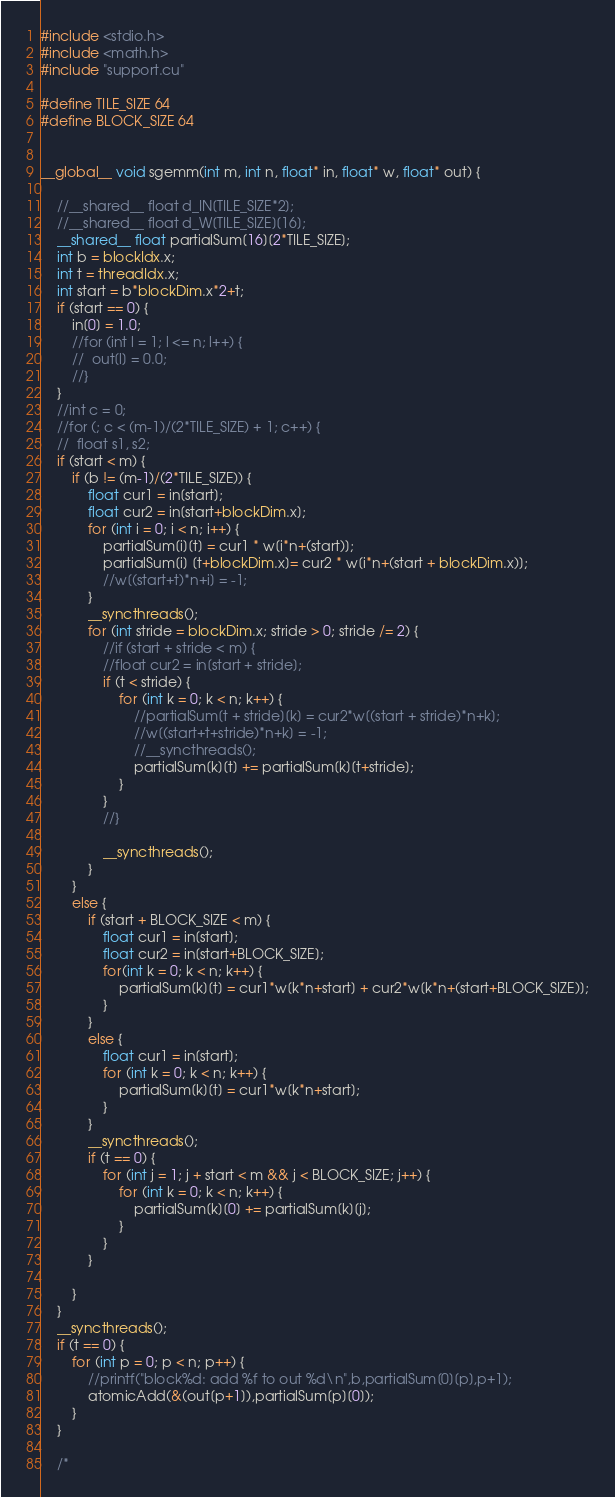Convert code to text. <code><loc_0><loc_0><loc_500><loc_500><_Cuda_>#include <stdio.h>
#include <math.h>
#include "support.cu"

#define TILE_SIZE 64
#define BLOCK_SIZE 64


__global__ void sgemm(int m, int n, float* in, float* w, float* out) {

	//__shared__ float d_IN[TILE_SIZE*2];
	//__shared__ float d_W[TILE_SIZE][16];
	__shared__ float partialSum[16][2*TILE_SIZE];
	int b = blockIdx.x;
	int t = threadIdx.x;
	int start = b*blockDim.x*2+t;
	if (start == 0) {
		in[0] = 1.0;
		//for (int l = 1; l <= n; l++) {
		//	out[l] = 0.0;
		//}
	}
	//int c = 0;
	//for (; c < (m-1)/(2*TILE_SIZE) + 1; c++) {
	//	float s1, s2;
	if (start < m) {
		if (b != (m-1)/(2*TILE_SIZE)) {
			float cur1 = in[start];
			float cur2 = in[start+blockDim.x];
			for (int i = 0; i < n; i++) {			
				partialSum[i][t] = cur1 * w[i*n+(start)];
				partialSum[i] [t+blockDim.x]= cur2 * w[i*n+(start + blockDim.x)];
				//w[(start+t)*n+i] = -1;
			}
			__syncthreads();
			for (int stride = blockDim.x; stride > 0; stride /= 2) {
				//if (start + stride < m) {
				//float cur2 = in[start + stride];
				if (t < stride) {
					for (int k = 0; k < n; k++) {
						//partialSum[t + stride][k] = cur2*w[(start + stride)*n+k];
						//w[(start+t+stride)*n+k] = -1;
						//__syncthreads();
						partialSum[k][t] += partialSum[k][t+stride];
					}
				}
				//}

				__syncthreads();
			}
		}
		else {
			if (start + BLOCK_SIZE < m) {
				float cur1 = in[start];
				float cur2 = in[start+BLOCK_SIZE];
				for(int k = 0; k < n; k++) {
					partialSum[k][t] = cur1*w[k*n+start] + cur2*w[k*n+(start+BLOCK_SIZE)];
				}
			}
			else {
				float cur1 = in[start];
				for (int k = 0; k < n; k++) {
					partialSum[k][t] = cur1*w[k*n+start];
				}
			}
			__syncthreads();
			if (t == 0) {
				for (int j = 1; j + start < m && j < BLOCK_SIZE; j++) {
					for (int k = 0; k < n; k++) {
						partialSum[k][0] += partialSum[k][j];
					}
				}
			} 	

		}
	}
	__syncthreads();
	if (t == 0) {
		for (int p = 0; p < n; p++) {
			//printf("block%d: add %f to out %d\n",b,partialSum[0][p],p+1);
			atomicAdd(&(out[p+1]),partialSum[p][0]);
		}
	}

	/*</code> 